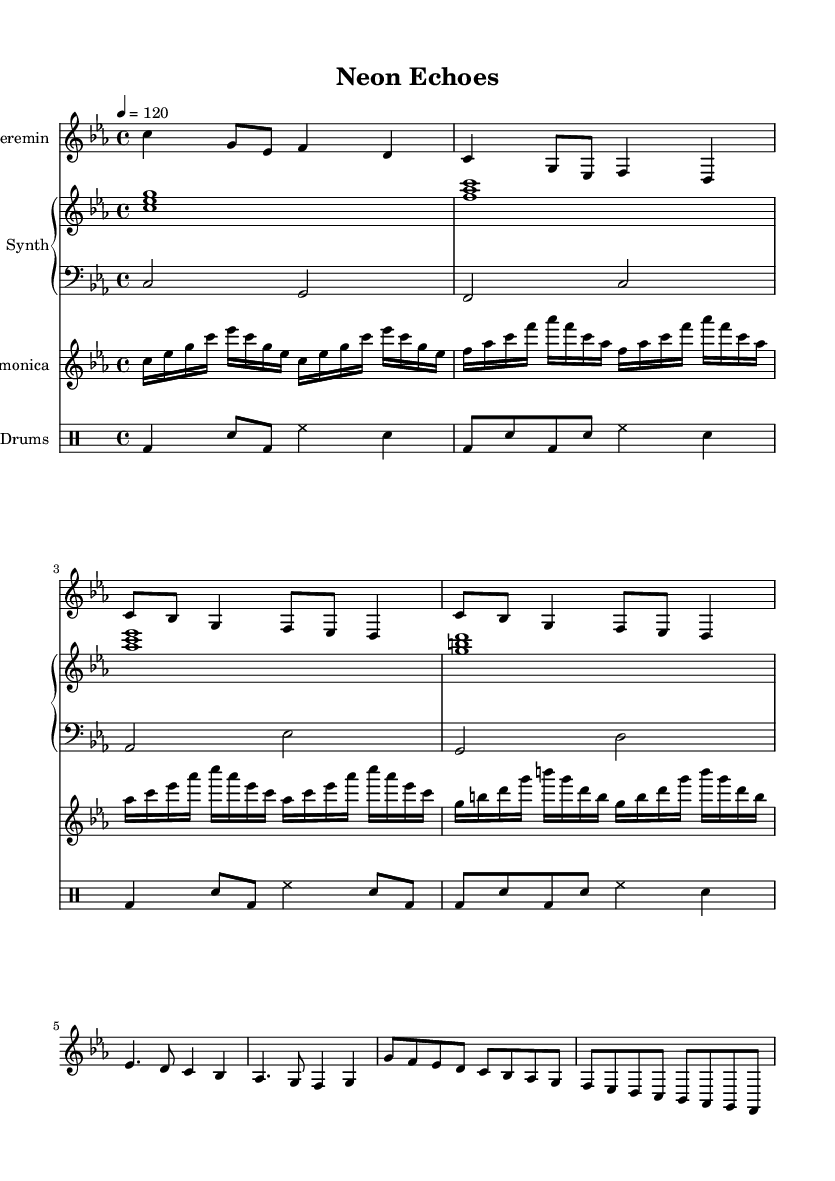What is the key signature of this music? The key signature is indicated at the beginning of the sheet music. It shows 3 flat symbols, which represent the key of C minor.
Answer: C minor What is the time signature of this music? The time signature is displayed at the beginning of the score. It shows 4 over 4, indicating a common time.
Answer: 4/4 What is the tempo marking for this piece? The tempo marking is found at the beginning of the score, which indicates a speed of 120 beats per minute.
Answer: 120 How many measures are in the Theremin part? By counting the number of vertical lines (bar lines) in the Theremin part, there are a total of 8 measures.
Answer: 8 What is the highest note in the Glass Harmonica part? The Glass Harmonica part reaches the note high C, which is identified as the highest note in the written music.
Answer: C How many instruments are featured in this score? The score includes 4 distinct instrument parts: Theremin, Synth, Glass Harmonica, and E. Drums, which can be counted from the staff headings.
Answer: 4 What musical elements are combined in this experimental pop piece? The score includes unconventional instruments like the Theremin and Glass Harmonica, along with electronic elements from the Synth and digital drums, indicating a fusion of styles.
Answer: Theremin, Glass Harmonica, Synth, E. Drums 